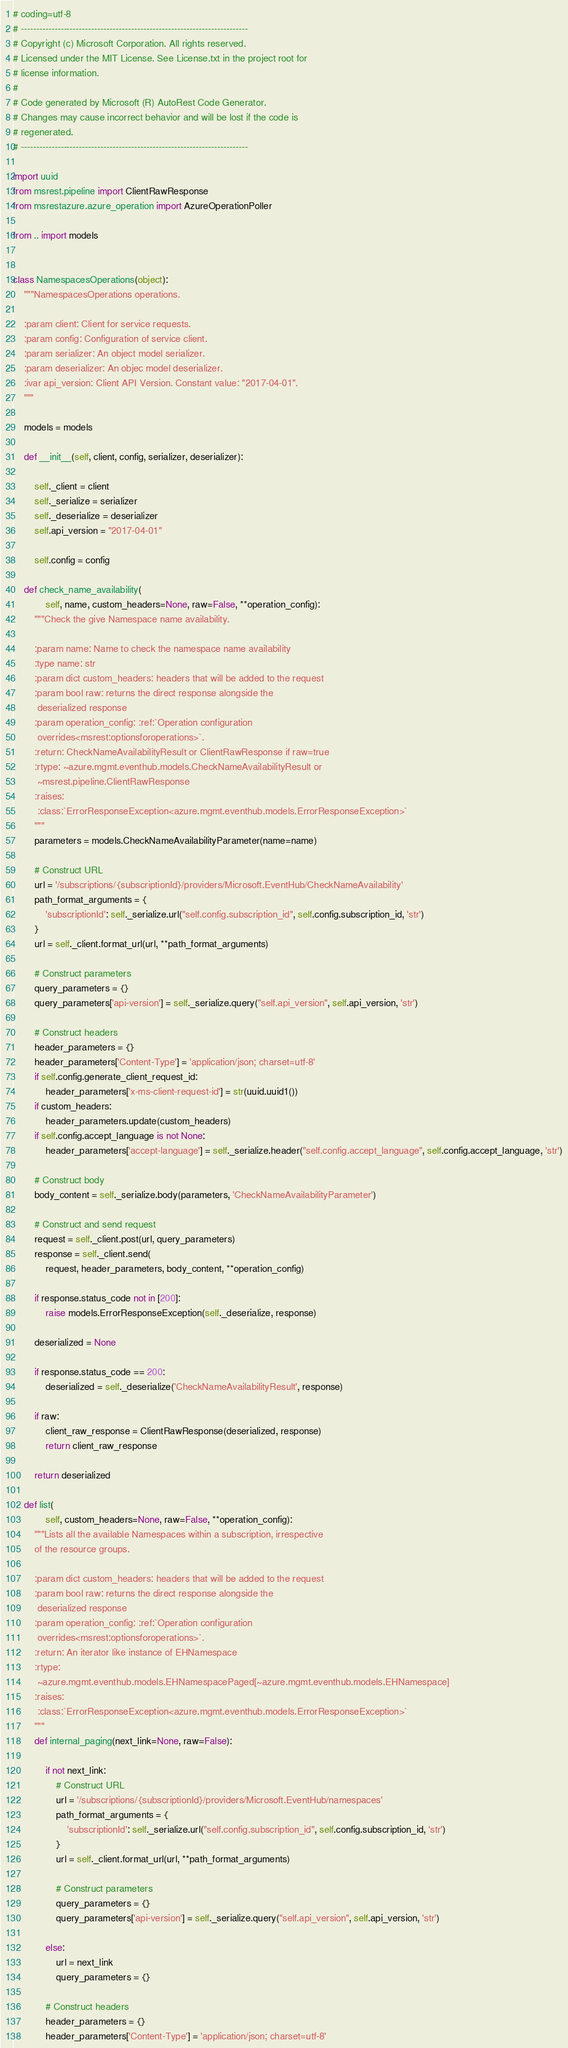Convert code to text. <code><loc_0><loc_0><loc_500><loc_500><_Python_># coding=utf-8
# --------------------------------------------------------------------------
# Copyright (c) Microsoft Corporation. All rights reserved.
# Licensed under the MIT License. See License.txt in the project root for
# license information.
#
# Code generated by Microsoft (R) AutoRest Code Generator.
# Changes may cause incorrect behavior and will be lost if the code is
# regenerated.
# --------------------------------------------------------------------------

import uuid
from msrest.pipeline import ClientRawResponse
from msrestazure.azure_operation import AzureOperationPoller

from .. import models


class NamespacesOperations(object):
    """NamespacesOperations operations.

    :param client: Client for service requests.
    :param config: Configuration of service client.
    :param serializer: An object model serializer.
    :param deserializer: An objec model deserializer.
    :ivar api_version: Client API Version. Constant value: "2017-04-01".
    """

    models = models

    def __init__(self, client, config, serializer, deserializer):

        self._client = client
        self._serialize = serializer
        self._deserialize = deserializer
        self.api_version = "2017-04-01"

        self.config = config

    def check_name_availability(
            self, name, custom_headers=None, raw=False, **operation_config):
        """Check the give Namespace name availability.

        :param name: Name to check the namespace name availability
        :type name: str
        :param dict custom_headers: headers that will be added to the request
        :param bool raw: returns the direct response alongside the
         deserialized response
        :param operation_config: :ref:`Operation configuration
         overrides<msrest:optionsforoperations>`.
        :return: CheckNameAvailabilityResult or ClientRawResponse if raw=true
        :rtype: ~azure.mgmt.eventhub.models.CheckNameAvailabilityResult or
         ~msrest.pipeline.ClientRawResponse
        :raises:
         :class:`ErrorResponseException<azure.mgmt.eventhub.models.ErrorResponseException>`
        """
        parameters = models.CheckNameAvailabilityParameter(name=name)

        # Construct URL
        url = '/subscriptions/{subscriptionId}/providers/Microsoft.EventHub/CheckNameAvailability'
        path_format_arguments = {
            'subscriptionId': self._serialize.url("self.config.subscription_id", self.config.subscription_id, 'str')
        }
        url = self._client.format_url(url, **path_format_arguments)

        # Construct parameters
        query_parameters = {}
        query_parameters['api-version'] = self._serialize.query("self.api_version", self.api_version, 'str')

        # Construct headers
        header_parameters = {}
        header_parameters['Content-Type'] = 'application/json; charset=utf-8'
        if self.config.generate_client_request_id:
            header_parameters['x-ms-client-request-id'] = str(uuid.uuid1())
        if custom_headers:
            header_parameters.update(custom_headers)
        if self.config.accept_language is not None:
            header_parameters['accept-language'] = self._serialize.header("self.config.accept_language", self.config.accept_language, 'str')

        # Construct body
        body_content = self._serialize.body(parameters, 'CheckNameAvailabilityParameter')

        # Construct and send request
        request = self._client.post(url, query_parameters)
        response = self._client.send(
            request, header_parameters, body_content, **operation_config)

        if response.status_code not in [200]:
            raise models.ErrorResponseException(self._deserialize, response)

        deserialized = None

        if response.status_code == 200:
            deserialized = self._deserialize('CheckNameAvailabilityResult', response)

        if raw:
            client_raw_response = ClientRawResponse(deserialized, response)
            return client_raw_response

        return deserialized

    def list(
            self, custom_headers=None, raw=False, **operation_config):
        """Lists all the available Namespaces within a subscription, irrespective
        of the resource groups.

        :param dict custom_headers: headers that will be added to the request
        :param bool raw: returns the direct response alongside the
         deserialized response
        :param operation_config: :ref:`Operation configuration
         overrides<msrest:optionsforoperations>`.
        :return: An iterator like instance of EHNamespace
        :rtype:
         ~azure.mgmt.eventhub.models.EHNamespacePaged[~azure.mgmt.eventhub.models.EHNamespace]
        :raises:
         :class:`ErrorResponseException<azure.mgmt.eventhub.models.ErrorResponseException>`
        """
        def internal_paging(next_link=None, raw=False):

            if not next_link:
                # Construct URL
                url = '/subscriptions/{subscriptionId}/providers/Microsoft.EventHub/namespaces'
                path_format_arguments = {
                    'subscriptionId': self._serialize.url("self.config.subscription_id", self.config.subscription_id, 'str')
                }
                url = self._client.format_url(url, **path_format_arguments)

                # Construct parameters
                query_parameters = {}
                query_parameters['api-version'] = self._serialize.query("self.api_version", self.api_version, 'str')

            else:
                url = next_link
                query_parameters = {}

            # Construct headers
            header_parameters = {}
            header_parameters['Content-Type'] = 'application/json; charset=utf-8'</code> 